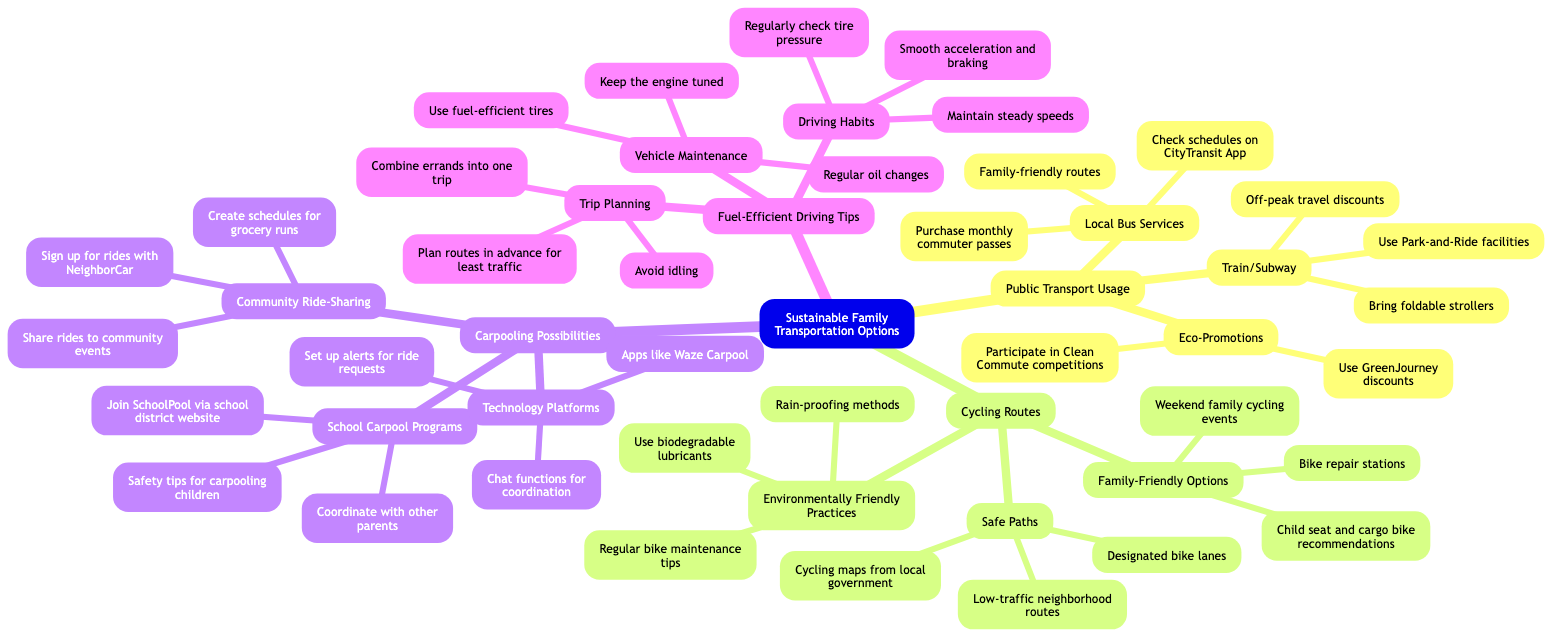What are two types of public transport listed? The diagram lists "Local Bus Services" and "Train/Subway" as types of public transport under "Public Transport Usage."
Answer: Local Bus Services, Train/Subway How many subcategories are under the "Cycling Routes" node? There are three subcategories listed under "Cycling Routes": "Safe Paths," "Family-Friendly Options," and "Environmentally Friendly Practices." This totals three subcategories.
Answer: 3 What is one eco-promotion mentioned for public transport? Under the "Eco-Promotions" node, one specific promotion mentioned is "Use GreenJourney discounts."
Answer: Use GreenJourney discounts Which driving habit is suggested for fuel efficiency? The diagram suggests "Smooth acceleration and braking" as one driving habit to improve fuel efficiency.
Answer: Smooth acceleration and braking What technology platform is recommended for carpooling? Under the "Technology Platforms" node, the diagram recommends the app "Waze Carpool" for carpooling possibilities.
Answer: Waze Carpool How should errands be planned according to "Trip Planning"? The diagram suggests that errands should be "combined into one trip" for efficient planning under the "Trip Planning" section.
Answer: Combine errands into one trip What type of bike is recommended for family-friendly cycling options? The "Family-Friendly Options" subcategory mentions "child seat and cargo bike recommendations" as options for families.
Answer: Child seat and cargo bike recommendations What is one way to maintain safe cycling paths? "Designated bike lanes" is listed as a method to ensure safe paths for cycling.
Answer: Designated bike lanes 